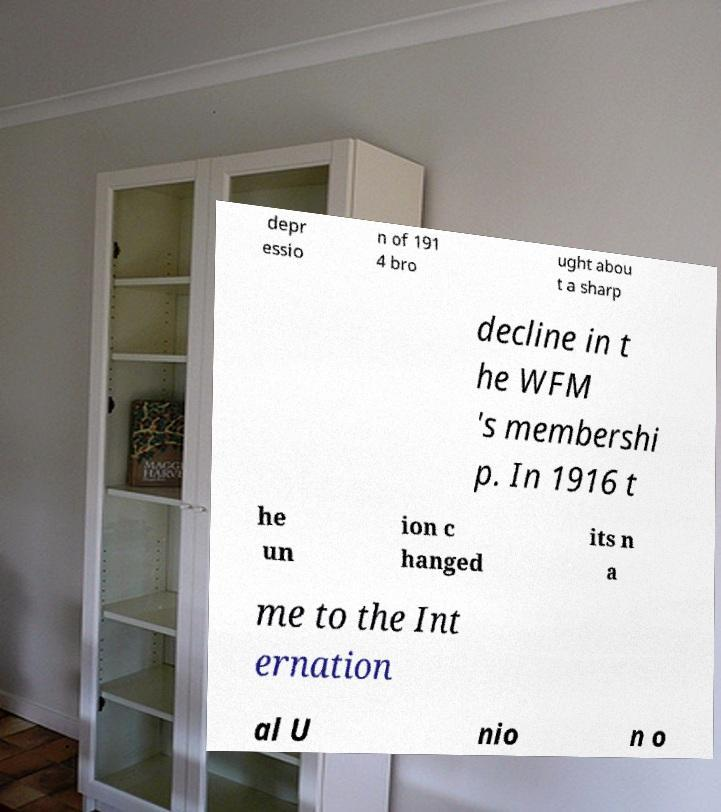For documentation purposes, I need the text within this image transcribed. Could you provide that? depr essio n of 191 4 bro ught abou t a sharp decline in t he WFM 's membershi p. In 1916 t he un ion c hanged its n a me to the Int ernation al U nio n o 